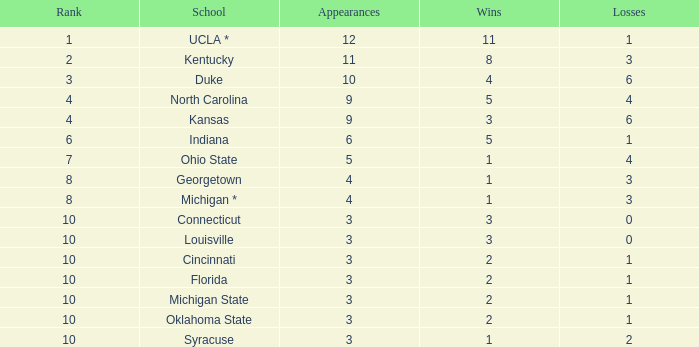Tell me the average Rank for lossess less than 6 and wins less than 11 for michigan state 10.0. 